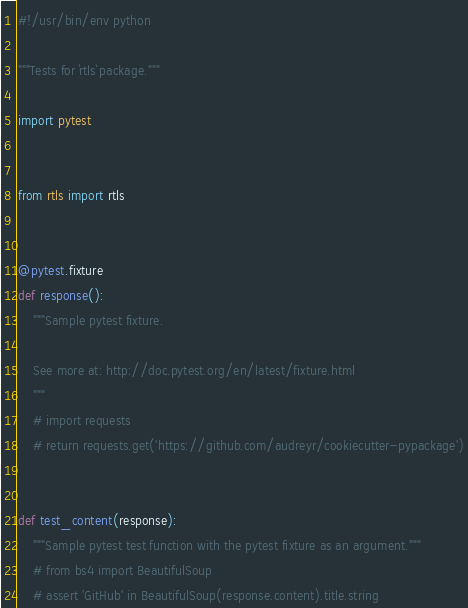<code> <loc_0><loc_0><loc_500><loc_500><_Python_>#!/usr/bin/env python

"""Tests for `rtls` package."""

import pytest


from rtls import rtls


@pytest.fixture
def response():
    """Sample pytest fixture.

    See more at: http://doc.pytest.org/en/latest/fixture.html
    """
    # import requests
    # return requests.get('https://github.com/audreyr/cookiecutter-pypackage')


def test_content(response):
    """Sample pytest test function with the pytest fixture as an argument."""
    # from bs4 import BeautifulSoup
    # assert 'GitHub' in BeautifulSoup(response.content).title.string
</code> 